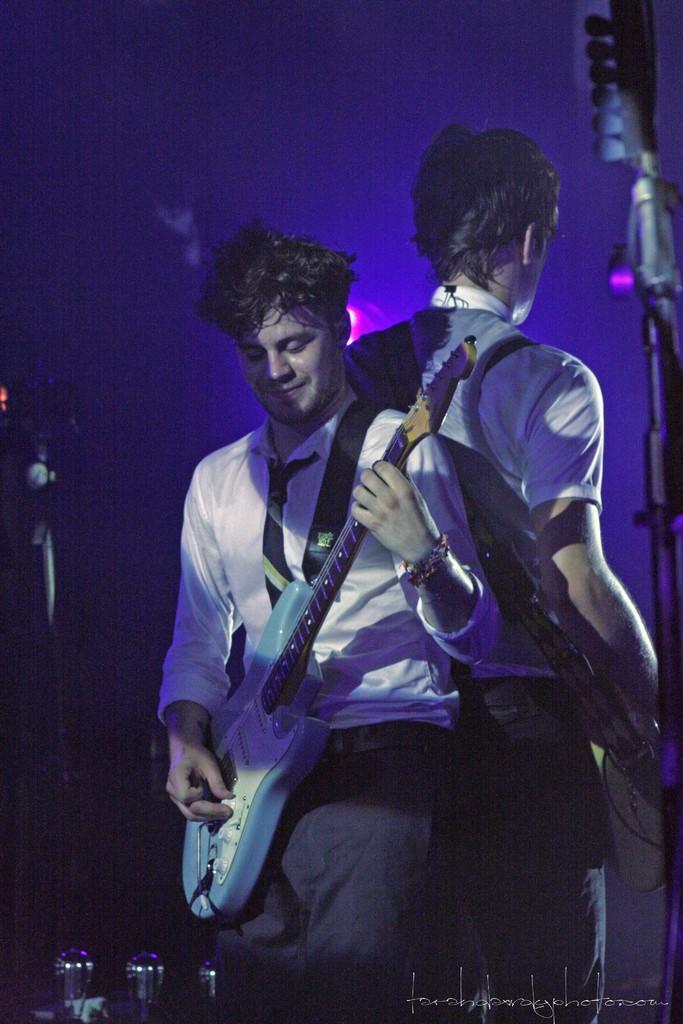In one or two sentences, can you explain what this image depicts? In this image we can see two persons standing and playing the musical instruments, there are poles and lights, at the bottom of the image we can see the text. 